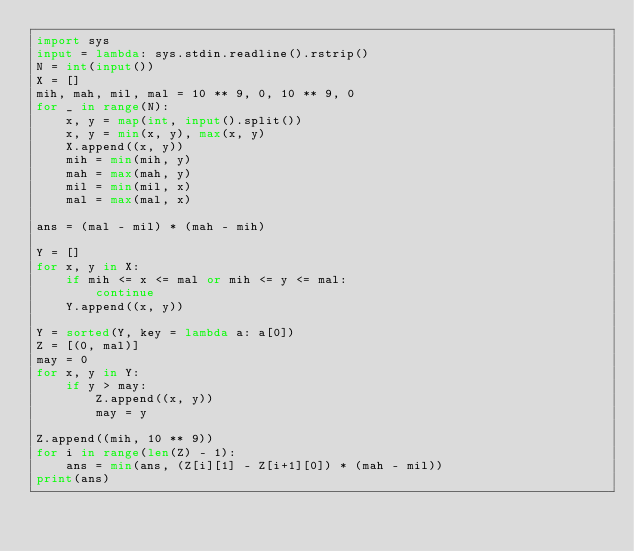<code> <loc_0><loc_0><loc_500><loc_500><_Python_>import sys
input = lambda: sys.stdin.readline().rstrip()
N = int(input())
X = []
mih, mah, mil, mal = 10 ** 9, 0, 10 ** 9, 0
for _ in range(N):
    x, y = map(int, input().split())
    x, y = min(x, y), max(x, y)
    X.append((x, y))
    mih = min(mih, y)
    mah = max(mah, y)
    mil = min(mil, x)
    mal = max(mal, x)

ans = (mal - mil) * (mah - mih)

Y = []
for x, y in X:
    if mih <= x <= mal or mih <= y <= mal:
        continue
    Y.append((x, y))

Y = sorted(Y, key = lambda a: a[0])
Z = [(0, mal)]
may = 0
for x, y in Y:
    if y > may:
        Z.append((x, y))
        may = y

Z.append((mih, 10 ** 9))
for i in range(len(Z) - 1):
    ans = min(ans, (Z[i][1] - Z[i+1][0]) * (mah - mil))
print(ans)</code> 